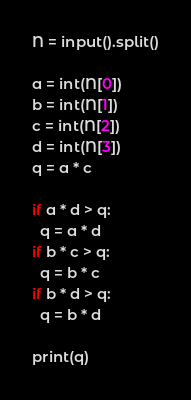<code> <loc_0><loc_0><loc_500><loc_500><_Python_>N = input().split()

a = int(N[0])
b = int(N[1])
c = int(N[2])
d = int(N[3])
q = a * c 

if a * d > q:
  q = a * d
if b * c > q:
  q = b * c
if b * d > q:
  q = b * d

print(q)</code> 